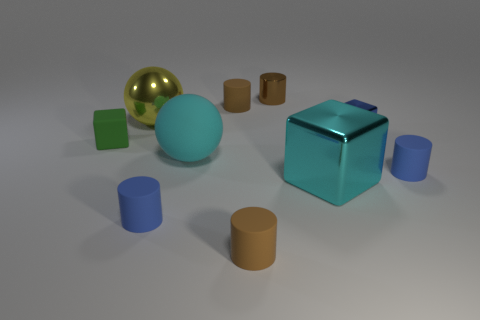Is the color of the large matte thing the same as the metallic cylinder?
Provide a succinct answer. No. There is a cube that is the same color as the big matte sphere; what is its material?
Ensure brevity in your answer.  Metal. The yellow thing has what shape?
Provide a succinct answer. Sphere. There is a blue cylinder that is right of the cyan matte ball; what is it made of?
Ensure brevity in your answer.  Rubber. Is there a small cylinder that has the same color as the matte cube?
Your response must be concise. No. There is a yellow metal object that is the same size as the cyan matte sphere; what shape is it?
Your response must be concise. Sphere. What is the color of the big shiny thing that is in front of the big yellow object?
Your response must be concise. Cyan. There is a big metallic object in front of the green cube; is there a brown rubber thing that is to the right of it?
Offer a terse response. No. How many things are either small blue things that are behind the green rubber block or big metallic balls?
Provide a short and direct response. 2. Is there anything else that has the same size as the green object?
Provide a short and direct response. Yes. 